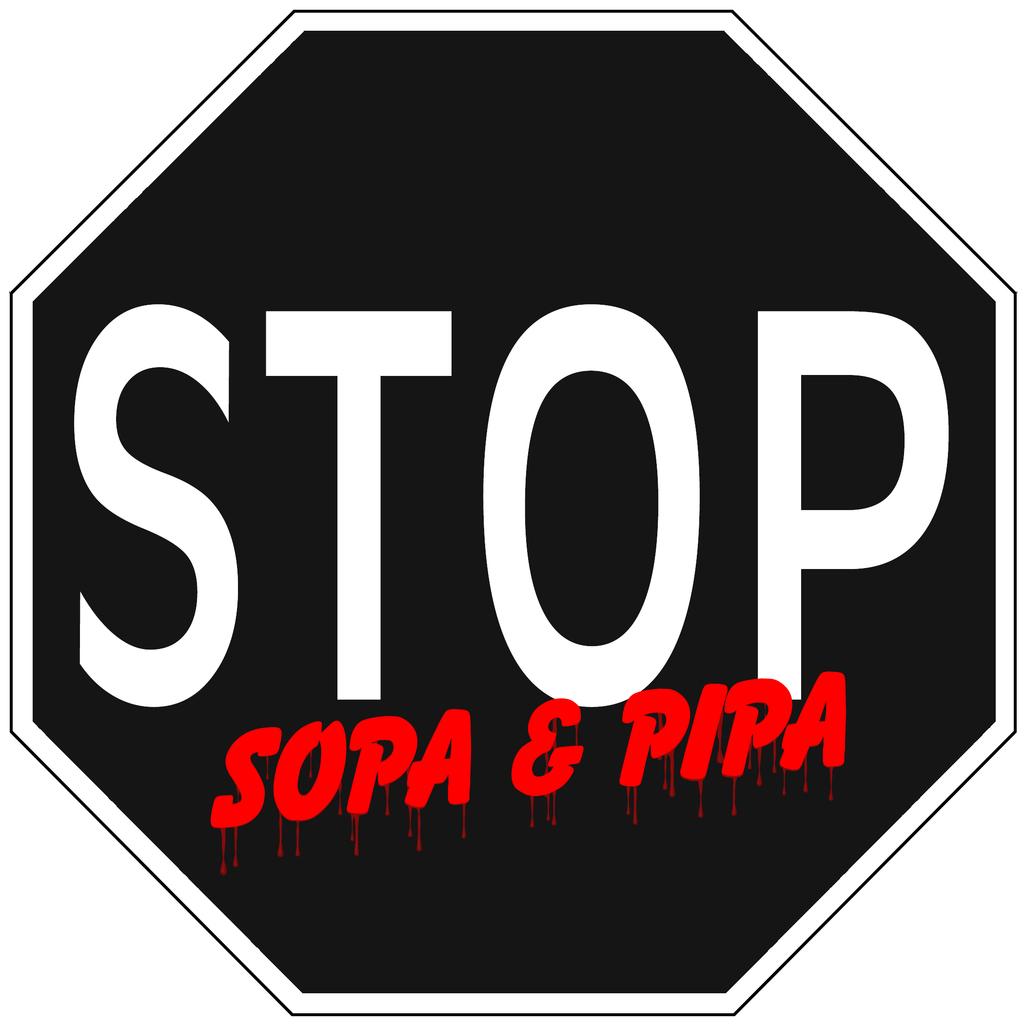What kind of street sign is this based on?
Make the answer very short. Stop. 